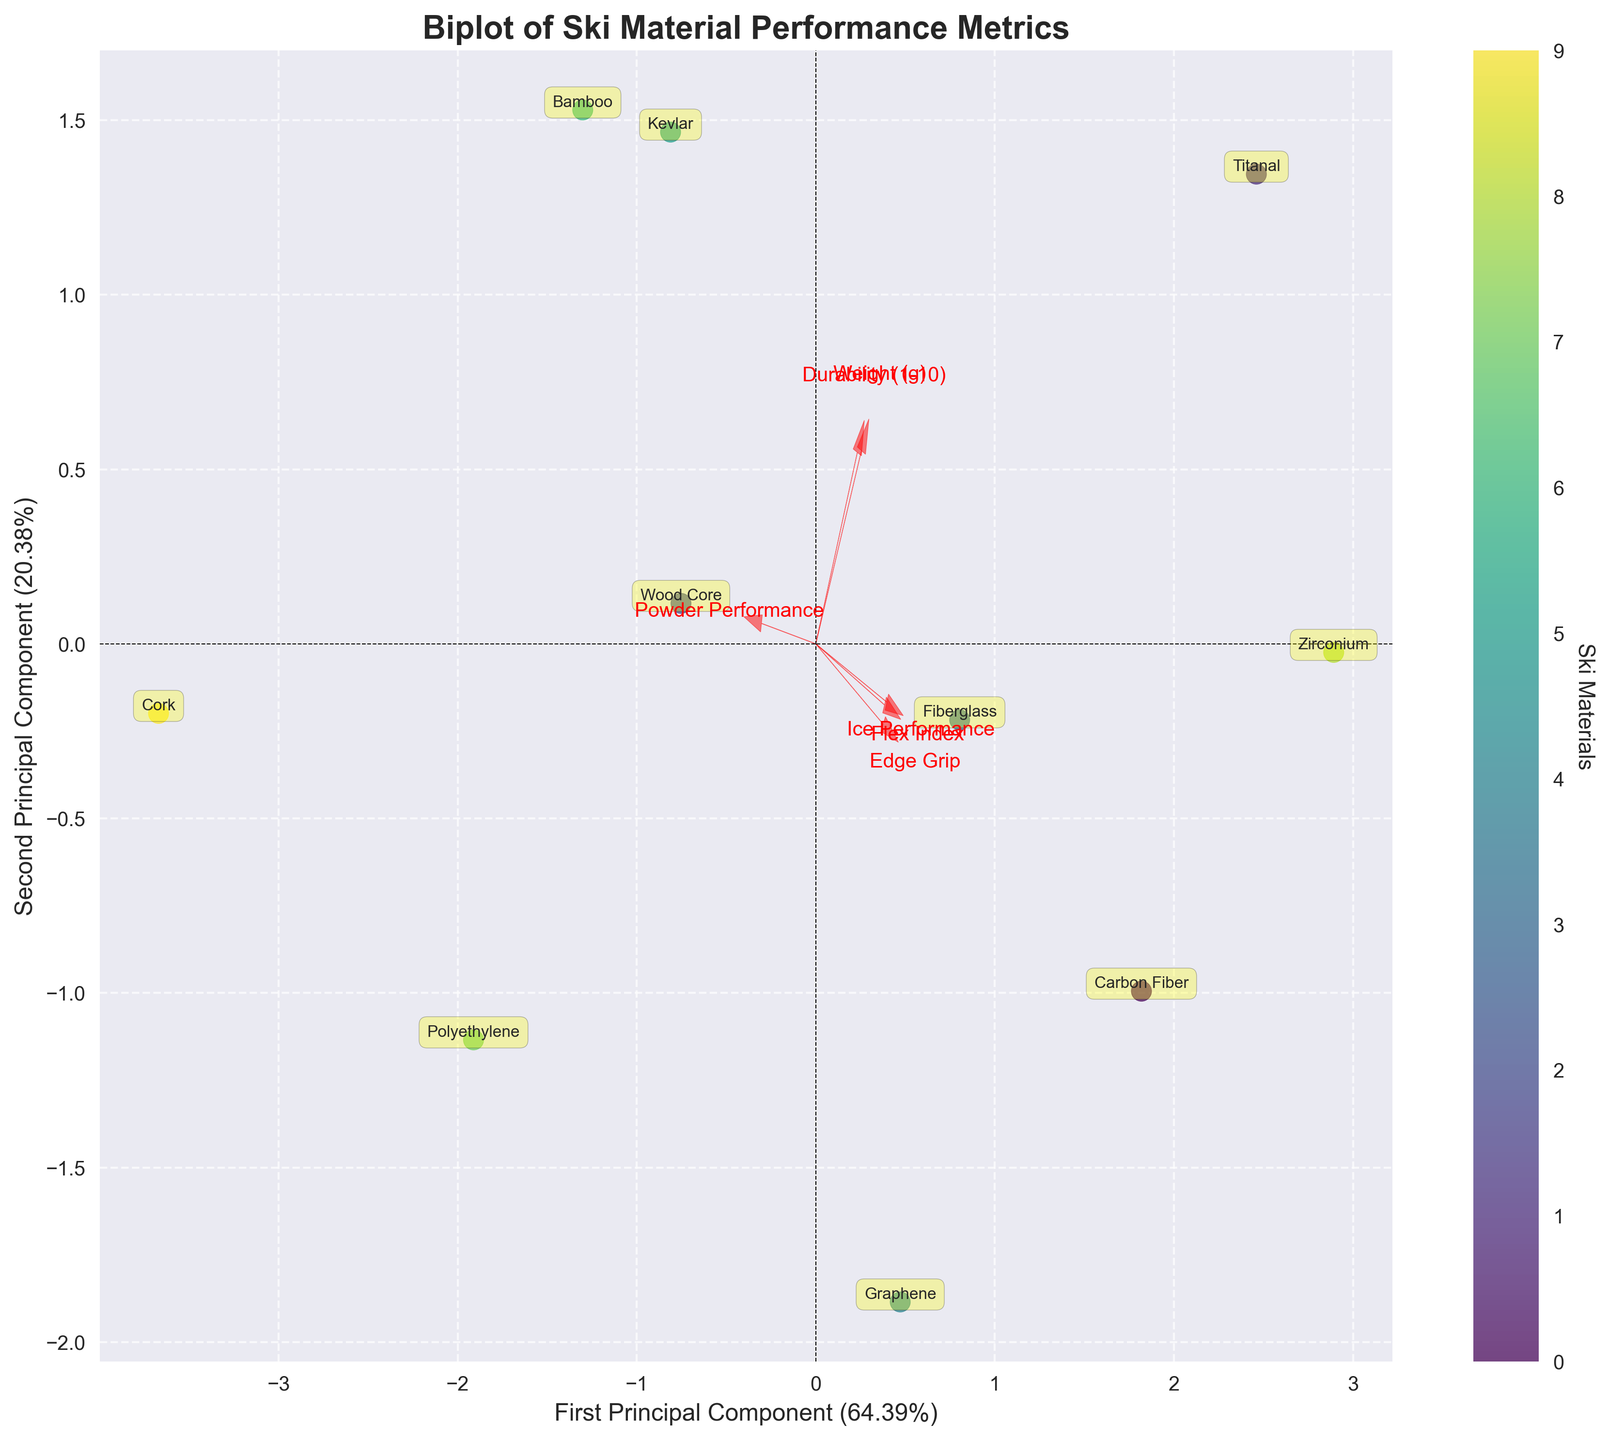How many ski materials are represented in the biplot? The biplot has one data point for each ski material. To find the number of ski materials, count the data points.
Answer: 10 What is the title of the biplot? The title of the biplot is usually displayed at the top above the plot area.
Answer: Biplot of Ski Material Performance Metrics What is labeled on the x-axis? The label on the x-axis is provided below the x-axis line.
Answer: First Principal Component Which ski material has the highest Flex Index according to the biplot? The Flex Index is associated with the first Principal Component. Zirconium has the highest Flex Index as it has the highest score along the corresponding component in the direction indicated by the feature vector.
Answer: Zirconium What do the red arrows in the biplot represent? Red arrows represent the feature vectors, showing the direction and magnitude of each original variable in the principal component space.
Answer: Feature vectors Which ski material is closest to the origin of the biplot? Identify the ski material whose data point is nearest to the center (0,0) of the biplot.
Answer: Polyethylene Which ski material is furthest in the direction of the Weight (g) feature vector? Follow the direction of the red arrow associated with the Weight (g) label and find the ski material furthest along that line.
Answer: Titanal Which features seem to separate Carbon Fiber and Cork the most? Look at the direction and length of feature vectors pointing to opposite sides where Carbon Fiber and Cork lie. Flex Index, Ice Performance, and Edge Grip seem to separate them most because these feature vectors are aligned with their distances.
Answer: Flex Index, Ice Performance, Edge Grip Between Graphene and Cork, which ski material is better for Powder Performance? Powder Performance has its vector pointing towards the positive second Principal Component. Identify the ski material closer to that direction.
Answer: Cork Which ski materials have the highest value for the first Principal Component? Identify the data points furthest to the right side along the x-axis, which denotes the first Principal Component.
Answer: Zirconium, Graphene 